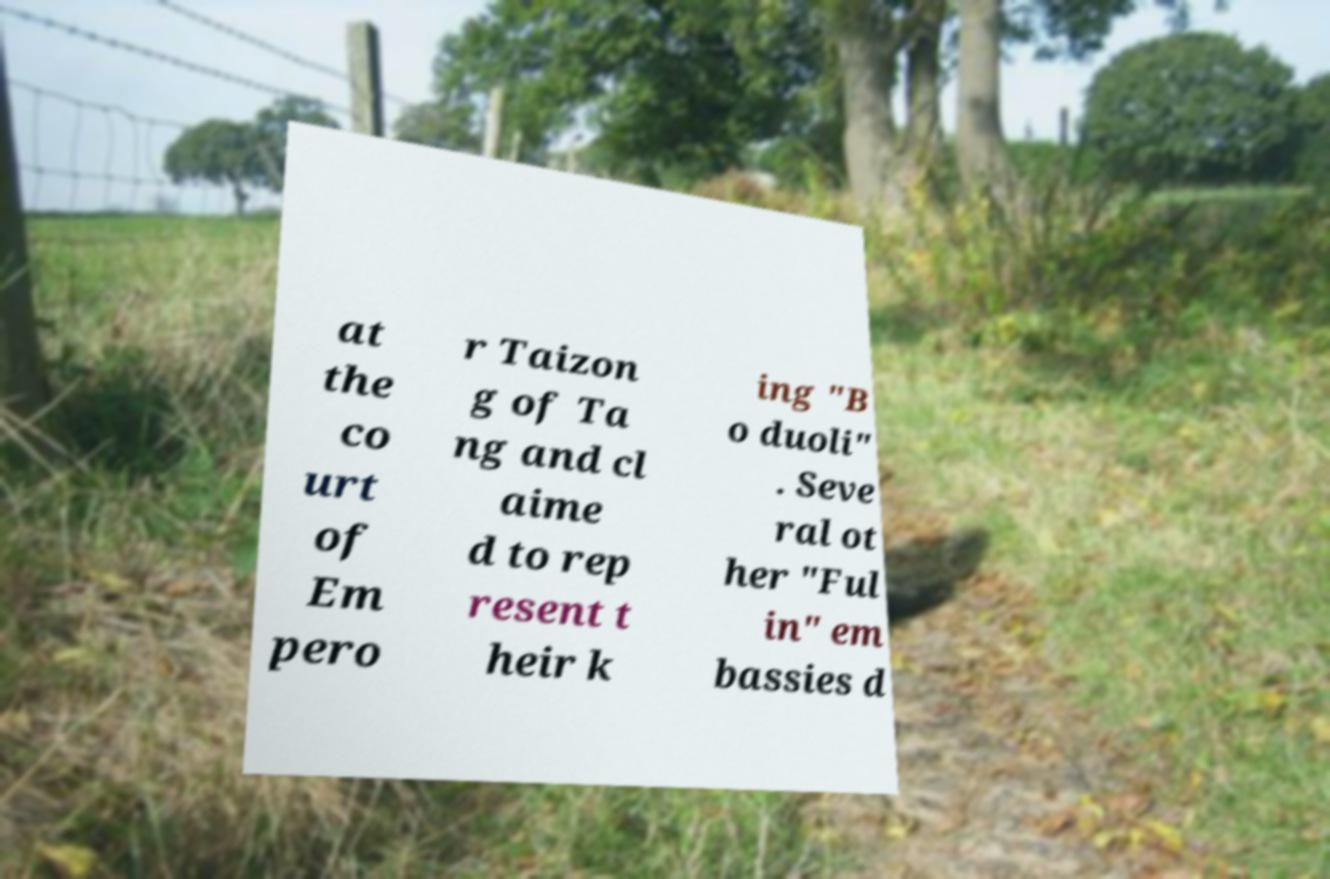Can you read and provide the text displayed in the image?This photo seems to have some interesting text. Can you extract and type it out for me? at the co urt of Em pero r Taizon g of Ta ng and cl aime d to rep resent t heir k ing "B o duoli" . Seve ral ot her "Ful in" em bassies d 